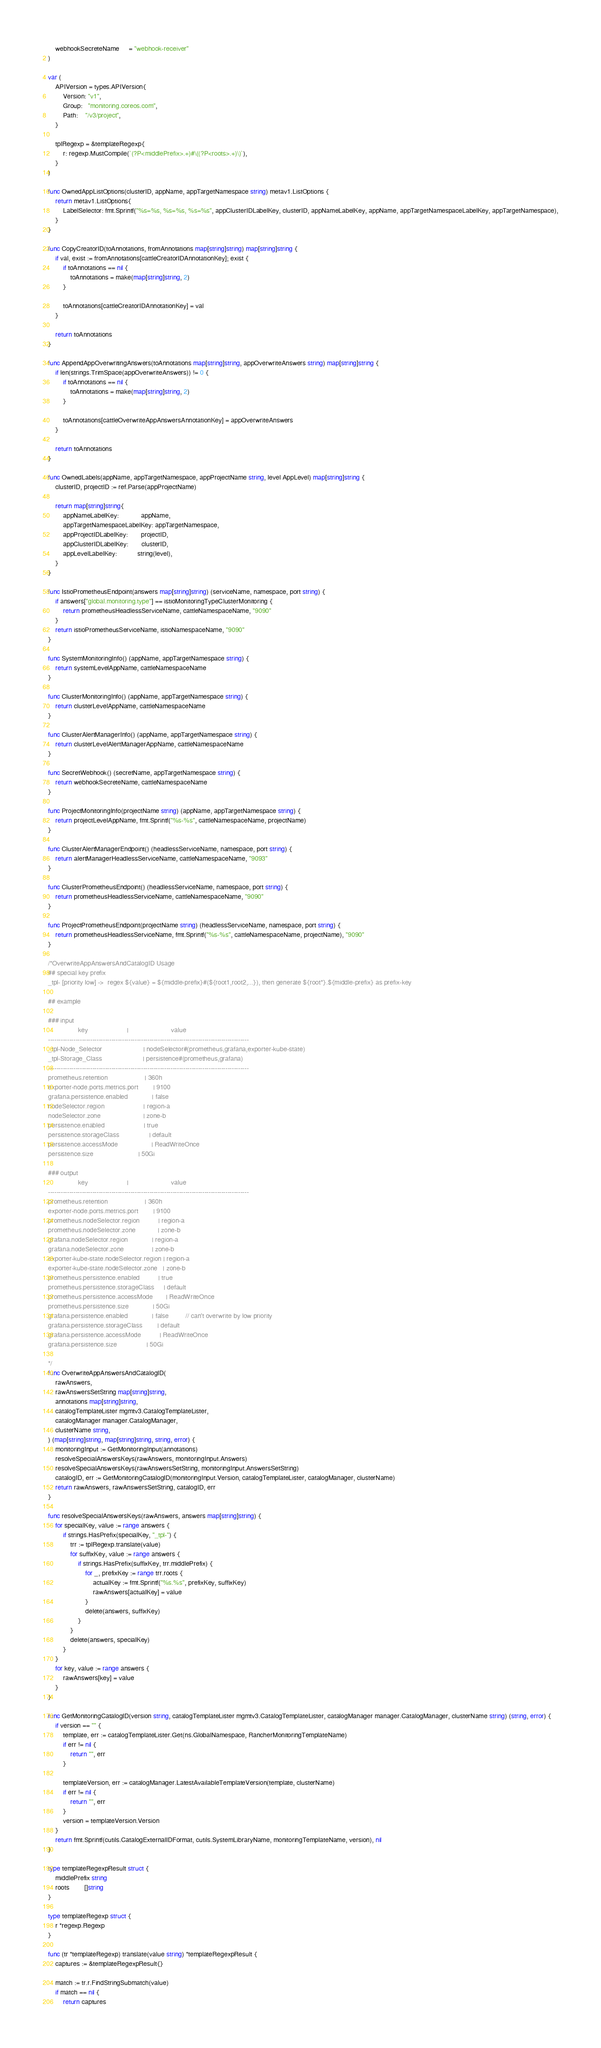Convert code to text. <code><loc_0><loc_0><loc_500><loc_500><_Go_>	webhookSecreteName     = "webhook-receiver"
)

var (
	APIVersion = types.APIVersion{
		Version: "v1",
		Group:   "monitoring.coreos.com",
		Path:    "/v3/project",
	}

	tplRegexp = &templateRegexp{
		r: regexp.MustCompile(`(?P<middlePrefix>.+)#\((?P<roots>.+)\)`),
	}
)

func OwnedAppListOptions(clusterID, appName, appTargetNamespace string) metav1.ListOptions {
	return metav1.ListOptions{
		LabelSelector: fmt.Sprintf("%s=%s, %s=%s, %s=%s", appClusterIDLabelKey, clusterID, appNameLabelKey, appName, appTargetNamespaceLabelKey, appTargetNamespace),
	}
}

func CopyCreatorID(toAnnotations, fromAnnotations map[string]string) map[string]string {
	if val, exist := fromAnnotations[cattleCreatorIDAnnotationKey]; exist {
		if toAnnotations == nil {
			toAnnotations = make(map[string]string, 2)
		}

		toAnnotations[cattleCreatorIDAnnotationKey] = val
	}

	return toAnnotations
}

func AppendAppOverwritingAnswers(toAnnotations map[string]string, appOverwriteAnswers string) map[string]string {
	if len(strings.TrimSpace(appOverwriteAnswers)) != 0 {
		if toAnnotations == nil {
			toAnnotations = make(map[string]string, 2)
		}

		toAnnotations[cattleOverwriteAppAnswersAnnotationKey] = appOverwriteAnswers
	}

	return toAnnotations
}

func OwnedLabels(appName, appTargetNamespace, appProjectName string, level AppLevel) map[string]string {
	clusterID, projectID := ref.Parse(appProjectName)

	return map[string]string{
		appNameLabelKey:            appName,
		appTargetNamespaceLabelKey: appTargetNamespace,
		appProjectIDLabelKey:       projectID,
		appClusterIDLabelKey:       clusterID,
		appLevelLabelKey:           string(level),
	}
}

func IstioPrometheusEndpoint(answers map[string]string) (serviceName, namespace, port string) {
	if answers["global.monitoring.type"] == istioMonitoringTypeClusterMonitoring {
		return prometheusHeadlessServiceName, cattleNamespaceName, "9090"
	}
	return istioPrometheusServiceName, istioNamespaceName, "9090"
}

func SystemMonitoringInfo() (appName, appTargetNamespace string) {
	return systemLevelAppName, cattleNamespaceName
}

func ClusterMonitoringInfo() (appName, appTargetNamespace string) {
	return clusterLevelAppName, cattleNamespaceName
}

func ClusterAlertManagerInfo() (appName, appTargetNamespace string) {
	return clusterLevelAlertManagerAppName, cattleNamespaceName
}

func SecretWebhook() (secretName, appTargetNamespace string) {
	return webhookSecreteName, cattleNamespaceName
}

func ProjectMonitoringInfo(projectName string) (appName, appTargetNamespace string) {
	return projectLevelAppName, fmt.Sprintf("%s-%s", cattleNamespaceName, projectName)
}

func ClusterAlertManagerEndpoint() (headlessServiceName, namespace, port string) {
	return alertManagerHeadlessServiceName, cattleNamespaceName, "9093"
}

func ClusterPrometheusEndpoint() (headlessServiceName, namespace, port string) {
	return prometheusHeadlessServiceName, cattleNamespaceName, "9090"
}

func ProjectPrometheusEndpoint(projectName string) (headlessServiceName, namespace, port string) {
	return prometheusHeadlessServiceName, fmt.Sprintf("%s-%s", cattleNamespaceName, projectName), "9090"
}

/*OverwriteAppAnswersAndCatalogID Usage
## special key prefix
_tpl- [priority low] ->  regex ${value} = ${middle-prefix}#(${root1,root2,...}), then generate ${root*}.${middle-prefix} as prefix-key

## example

### input
				key 				 	|           			value
-----------------------------------------------------------------------------------------------
_tpl-Node_Selector       	     		| nodeSelector#(prometheus,grafana,exporter-kube-state)
_tpl-Storage_Class       	     		| persistence#(prometheus,grafana)
-----------------------------------------------------------------------------------------------
prometheus.retention				 	| 360h
exporter-node.ports.metrics.port	 	| 9100
grafana.persistence.enabled             | false
nodeSelector.region		 				| region-a
nodeSelector.zone         				| zone-b
persistence.enabled       				| true
persistence.storageClass  				| default
persistence.accessMode    				| ReadWriteOnce
persistence.size          				| 50Gi

### output
				key 				 	|           			value
-----------------------------------------------------------------------------------------------
prometheus.retention				 	| 360h
exporter-node.ports.metrics.port	 	| 9100
prometheus.nodeSelector.region		 	| region-a
prometheus.nodeSelector.zone         	| zone-b
grafana.nodeSelector.region		 		| region-a
grafana.nodeSelector.zone         		| zone-b
exporter-kube-state.nodeSelector.region	| region-a
exporter-kube-state.nodeSelector.zone   | zone-b
prometheus.persistence.enabled       	| true
prometheus.persistence.storageClass  	| default
prometheus.persistence.accessMode    	| ReadWriteOnce
prometheus.persistence.size          	| 50Gi
grafana.persistence.enabled       	 	| false         // can't overwrite by low priority
grafana.persistence.storageClass     	| default
grafana.persistence.accessMode       	| ReadWriteOnce
grafana.persistence.size             	| 50Gi

*/
func OverwriteAppAnswersAndCatalogID(
	rawAnswers,
	rawAnswersSetString map[string]string,
	annotations map[string]string,
	catalogTemplateLister mgmtv3.CatalogTemplateLister,
	catalogManager manager.CatalogManager,
	clusterName string,
) (map[string]string, map[string]string, string, error) {
	monitoringInput := GetMonitoringInput(annotations)
	resolveSpecialAnswersKeys(rawAnswers, monitoringInput.Answers)
	resolveSpecialAnswersKeys(rawAnswersSetString, monitoringInput.AnswersSetString)
	catalogID, err := GetMonitoringCatalogID(monitoringInput.Version, catalogTemplateLister, catalogManager, clusterName)
	return rawAnswers, rawAnswersSetString, catalogID, err
}

func resolveSpecialAnswersKeys(rawAnswers, answers map[string]string) {
	for specialKey, value := range answers {
		if strings.HasPrefix(specialKey, "_tpl-") {
			trr := tplRegexp.translate(value)
			for suffixKey, value := range answers {
				if strings.HasPrefix(suffixKey, trr.middlePrefix) {
					for _, prefixKey := range trr.roots {
						actualKey := fmt.Sprintf("%s.%s", prefixKey, suffixKey)
						rawAnswers[actualKey] = value
					}
					delete(answers, suffixKey)
				}
			}
			delete(answers, specialKey)
		}
	}
	for key, value := range answers {
		rawAnswers[key] = value
	}
}

func GetMonitoringCatalogID(version string, catalogTemplateLister mgmtv3.CatalogTemplateLister, catalogManager manager.CatalogManager, clusterName string) (string, error) {
	if version == "" {
		template, err := catalogTemplateLister.Get(ns.GlobalNamespace, RancherMonitoringTemplateName)
		if err != nil {
			return "", err
		}

		templateVersion, err := catalogManager.LatestAvailableTemplateVersion(template, clusterName)
		if err != nil {
			return "", err
		}
		version = templateVersion.Version
	}
	return fmt.Sprintf(cutils.CatalogExternalIDFormat, cutils.SystemLibraryName, monitoringTemplateName, version), nil
}

type templateRegexpResult struct {
	middlePrefix string
	roots        []string
}

type templateRegexp struct {
	r *regexp.Regexp
}

func (tr *templateRegexp) translate(value string) *templateRegexpResult {
	captures := &templateRegexpResult{}

	match := tr.r.FindStringSubmatch(value)
	if match == nil {
		return captures</code> 